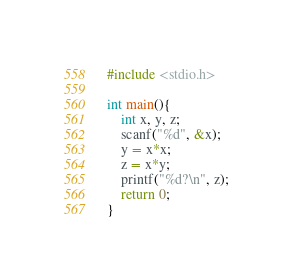<code> <loc_0><loc_0><loc_500><loc_500><_C_>#include <stdio.h>

int main(){
	int x, y, z;
	scanf("%d", &x);
	y = x*x;
	z = x*y;
	printf("%d?\n", z);
	return 0;
}</code> 